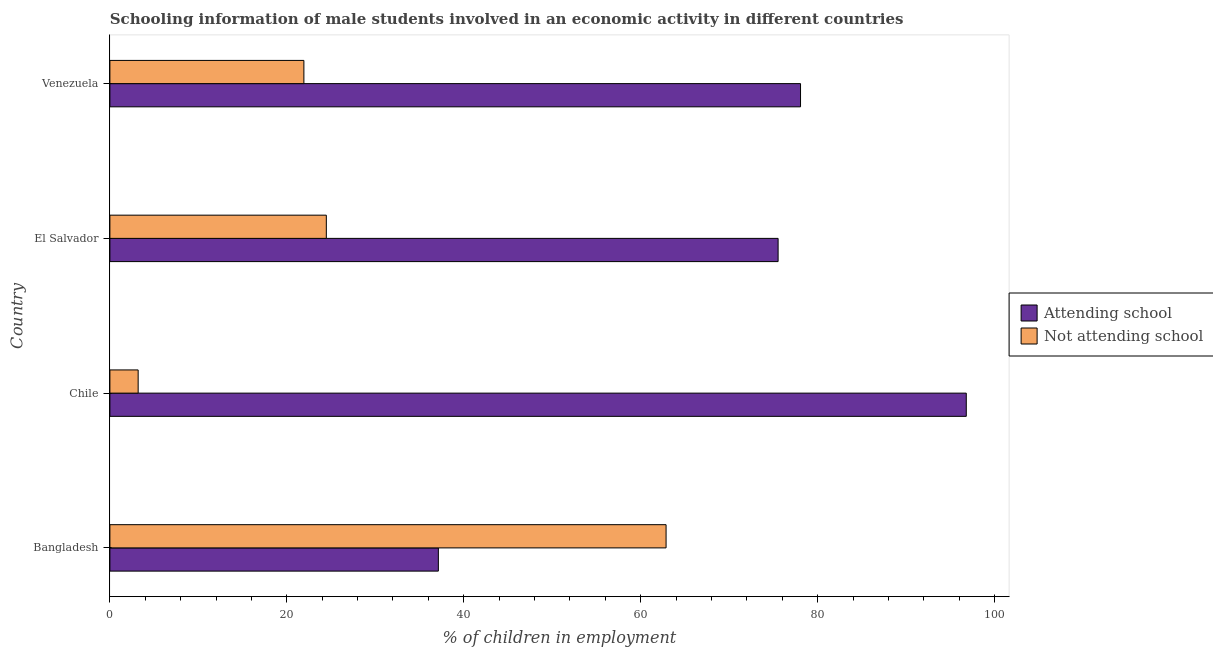Are the number of bars on each tick of the Y-axis equal?
Your answer should be compact. Yes. What is the label of the 4th group of bars from the top?
Ensure brevity in your answer.  Bangladesh. In how many cases, is the number of bars for a given country not equal to the number of legend labels?
Keep it short and to the point. 0. What is the percentage of employed males who are attending school in Bangladesh?
Provide a succinct answer. 37.13. Across all countries, what is the maximum percentage of employed males who are not attending school?
Your response must be concise. 62.87. Across all countries, what is the minimum percentage of employed males who are not attending school?
Provide a short and direct response. 3.19. In which country was the percentage of employed males who are not attending school minimum?
Your response must be concise. Chile. What is the total percentage of employed males who are attending school in the graph?
Give a very brief answer. 287.54. What is the difference between the percentage of employed males who are attending school in Bangladesh and that in Chile?
Give a very brief answer. -59.68. What is the difference between the percentage of employed males who are not attending school in Bangladesh and the percentage of employed males who are attending school in Venezuela?
Provide a short and direct response. -15.2. What is the average percentage of employed males who are not attending school per country?
Your answer should be very brief. 28.11. What is the difference between the percentage of employed males who are attending school and percentage of employed males who are not attending school in Chile?
Provide a short and direct response. 93.61. What is the ratio of the percentage of employed males who are not attending school in Chile to that in Venezuela?
Offer a very short reply. 0.15. What is the difference between the highest and the second highest percentage of employed males who are attending school?
Keep it short and to the point. 18.74. What is the difference between the highest and the lowest percentage of employed males who are not attending school?
Ensure brevity in your answer.  59.68. Is the sum of the percentage of employed males who are attending school in Bangladesh and Venezuela greater than the maximum percentage of employed males who are not attending school across all countries?
Ensure brevity in your answer.  Yes. What does the 1st bar from the top in Chile represents?
Give a very brief answer. Not attending school. What does the 2nd bar from the bottom in Bangladesh represents?
Offer a terse response. Not attending school. Are all the bars in the graph horizontal?
Ensure brevity in your answer.  Yes. How many countries are there in the graph?
Ensure brevity in your answer.  4. What is the difference between two consecutive major ticks on the X-axis?
Ensure brevity in your answer.  20. Are the values on the major ticks of X-axis written in scientific E-notation?
Provide a short and direct response. No. Does the graph contain any zero values?
Keep it short and to the point. No. Does the graph contain grids?
Your answer should be very brief. No. How are the legend labels stacked?
Provide a short and direct response. Vertical. What is the title of the graph?
Provide a short and direct response. Schooling information of male students involved in an economic activity in different countries. Does "Quality of trade" appear as one of the legend labels in the graph?
Offer a very short reply. No. What is the label or title of the X-axis?
Make the answer very short. % of children in employment. What is the label or title of the Y-axis?
Keep it short and to the point. Country. What is the % of children in employment in Attending school in Bangladesh?
Give a very brief answer. 37.13. What is the % of children in employment in Not attending school in Bangladesh?
Your answer should be compact. 62.87. What is the % of children in employment of Attending school in Chile?
Provide a succinct answer. 96.81. What is the % of children in employment in Not attending school in Chile?
Provide a succinct answer. 3.19. What is the % of children in employment in Attending school in El Salvador?
Offer a very short reply. 75.53. What is the % of children in employment in Not attending school in El Salvador?
Keep it short and to the point. 24.47. What is the % of children in employment of Attending school in Venezuela?
Make the answer very short. 78.07. What is the % of children in employment of Not attending school in Venezuela?
Offer a terse response. 21.93. Across all countries, what is the maximum % of children in employment of Attending school?
Give a very brief answer. 96.81. Across all countries, what is the maximum % of children in employment of Not attending school?
Offer a terse response. 62.87. Across all countries, what is the minimum % of children in employment of Attending school?
Ensure brevity in your answer.  37.13. Across all countries, what is the minimum % of children in employment of Not attending school?
Provide a short and direct response. 3.19. What is the total % of children in employment of Attending school in the graph?
Offer a very short reply. 287.54. What is the total % of children in employment in Not attending school in the graph?
Ensure brevity in your answer.  112.46. What is the difference between the % of children in employment of Attending school in Bangladesh and that in Chile?
Give a very brief answer. -59.68. What is the difference between the % of children in employment in Not attending school in Bangladesh and that in Chile?
Ensure brevity in your answer.  59.68. What is the difference between the % of children in employment of Attending school in Bangladesh and that in El Salvador?
Your answer should be very brief. -38.4. What is the difference between the % of children in employment in Not attending school in Bangladesh and that in El Salvador?
Your answer should be very brief. 38.4. What is the difference between the % of children in employment of Attending school in Bangladesh and that in Venezuela?
Make the answer very short. -40.94. What is the difference between the % of children in employment in Not attending school in Bangladesh and that in Venezuela?
Your answer should be very brief. 40.94. What is the difference between the % of children in employment in Attending school in Chile and that in El Salvador?
Offer a very short reply. 21.27. What is the difference between the % of children in employment in Not attending school in Chile and that in El Salvador?
Offer a very short reply. -21.27. What is the difference between the % of children in employment in Attending school in Chile and that in Venezuela?
Your response must be concise. 18.74. What is the difference between the % of children in employment in Not attending school in Chile and that in Venezuela?
Offer a very short reply. -18.74. What is the difference between the % of children in employment in Attending school in El Salvador and that in Venezuela?
Offer a very short reply. -2.54. What is the difference between the % of children in employment of Not attending school in El Salvador and that in Venezuela?
Provide a short and direct response. 2.54. What is the difference between the % of children in employment in Attending school in Bangladesh and the % of children in employment in Not attending school in Chile?
Offer a very short reply. 33.94. What is the difference between the % of children in employment of Attending school in Bangladesh and the % of children in employment of Not attending school in El Salvador?
Give a very brief answer. 12.66. What is the difference between the % of children in employment of Attending school in Bangladesh and the % of children in employment of Not attending school in Venezuela?
Your answer should be very brief. 15.2. What is the difference between the % of children in employment of Attending school in Chile and the % of children in employment of Not attending school in El Salvador?
Give a very brief answer. 72.34. What is the difference between the % of children in employment of Attending school in Chile and the % of children in employment of Not attending school in Venezuela?
Ensure brevity in your answer.  74.88. What is the difference between the % of children in employment of Attending school in El Salvador and the % of children in employment of Not attending school in Venezuela?
Give a very brief answer. 53.6. What is the average % of children in employment of Attending school per country?
Offer a terse response. 71.88. What is the average % of children in employment of Not attending school per country?
Offer a very short reply. 28.12. What is the difference between the % of children in employment of Attending school and % of children in employment of Not attending school in Bangladesh?
Provide a short and direct response. -25.74. What is the difference between the % of children in employment in Attending school and % of children in employment in Not attending school in Chile?
Your answer should be very brief. 93.61. What is the difference between the % of children in employment of Attending school and % of children in employment of Not attending school in El Salvador?
Give a very brief answer. 51.07. What is the difference between the % of children in employment in Attending school and % of children in employment in Not attending school in Venezuela?
Your answer should be very brief. 56.14. What is the ratio of the % of children in employment of Attending school in Bangladesh to that in Chile?
Give a very brief answer. 0.38. What is the ratio of the % of children in employment of Not attending school in Bangladesh to that in Chile?
Give a very brief answer. 19.68. What is the ratio of the % of children in employment of Attending school in Bangladesh to that in El Salvador?
Your answer should be compact. 0.49. What is the ratio of the % of children in employment of Not attending school in Bangladesh to that in El Salvador?
Offer a very short reply. 2.57. What is the ratio of the % of children in employment of Attending school in Bangladesh to that in Venezuela?
Offer a terse response. 0.48. What is the ratio of the % of children in employment of Not attending school in Bangladesh to that in Venezuela?
Provide a succinct answer. 2.87. What is the ratio of the % of children in employment of Attending school in Chile to that in El Salvador?
Give a very brief answer. 1.28. What is the ratio of the % of children in employment of Not attending school in Chile to that in El Salvador?
Keep it short and to the point. 0.13. What is the ratio of the % of children in employment of Attending school in Chile to that in Venezuela?
Make the answer very short. 1.24. What is the ratio of the % of children in employment of Not attending school in Chile to that in Venezuela?
Offer a terse response. 0.15. What is the ratio of the % of children in employment in Attending school in El Salvador to that in Venezuela?
Make the answer very short. 0.97. What is the ratio of the % of children in employment of Not attending school in El Salvador to that in Venezuela?
Your answer should be compact. 1.12. What is the difference between the highest and the second highest % of children in employment in Attending school?
Make the answer very short. 18.74. What is the difference between the highest and the second highest % of children in employment in Not attending school?
Give a very brief answer. 38.4. What is the difference between the highest and the lowest % of children in employment in Attending school?
Your answer should be compact. 59.68. What is the difference between the highest and the lowest % of children in employment in Not attending school?
Give a very brief answer. 59.68. 